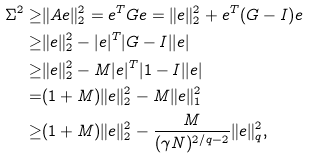<formula> <loc_0><loc_0><loc_500><loc_500>\Sigma ^ { 2 } \geq & \| { A } e \| _ { 2 } ^ { 2 } = e ^ { T } { G } e = \| e \| _ { 2 } ^ { 2 } + e ^ { T } { ( G - I ) } e \\ \geq & \| e \| _ { 2 } ^ { 2 } - | e | ^ { T } { | G - I | } | e | \\ \geq & \| e \| _ { 2 } ^ { 2 } - M | e | ^ { T } { | 1 - I | } | e | \\ = & ( 1 + M ) \| e \| _ { 2 } ^ { 2 } - M \| e \| _ { 1 } ^ { 2 } \\ \geq & ( 1 + M ) \| e \| _ { 2 } ^ { 2 } - \frac { M } { ( \gamma N ) ^ { 2 / q - 2 } } \| e \| _ { q } ^ { 2 } , \\</formula> 